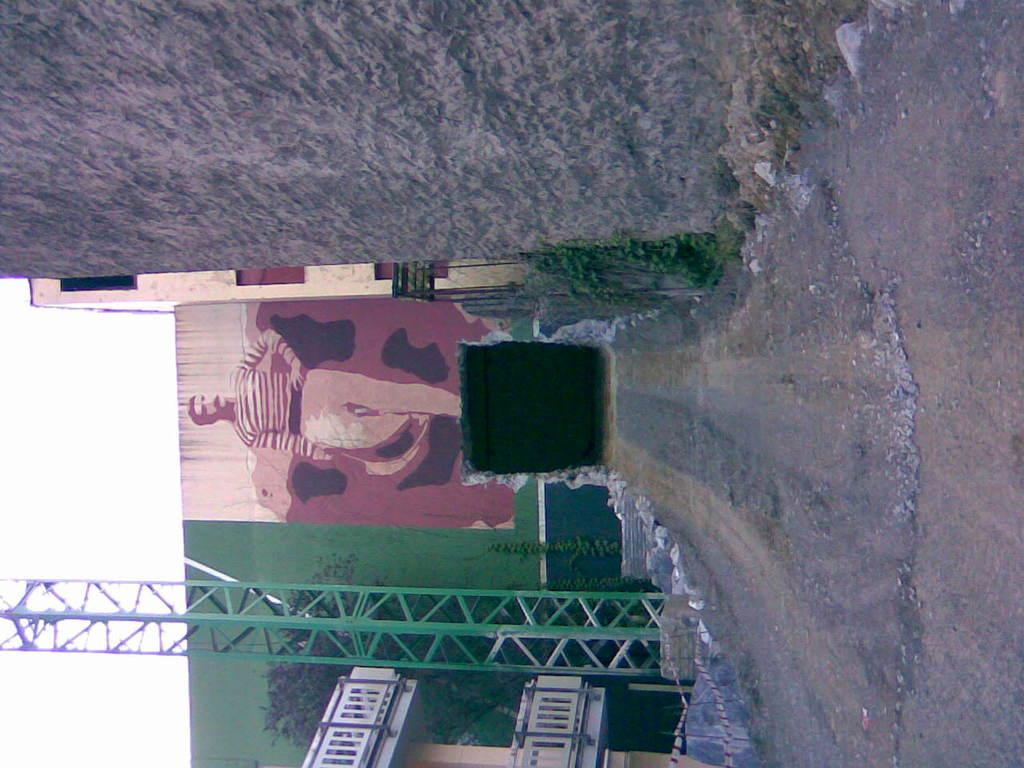What is depicted on the wall in the image? There is a painting of a man on the wall. What structure is located at the bottom of the image? There is a building at the bottom of the image. What is located beside the building? There is a pole beside the building. What can be seen on the left side of the image? The sky is visible on the left side of the image. How many family members are resting on the machine in the image? There is no family, rest, or machine present in the image. 